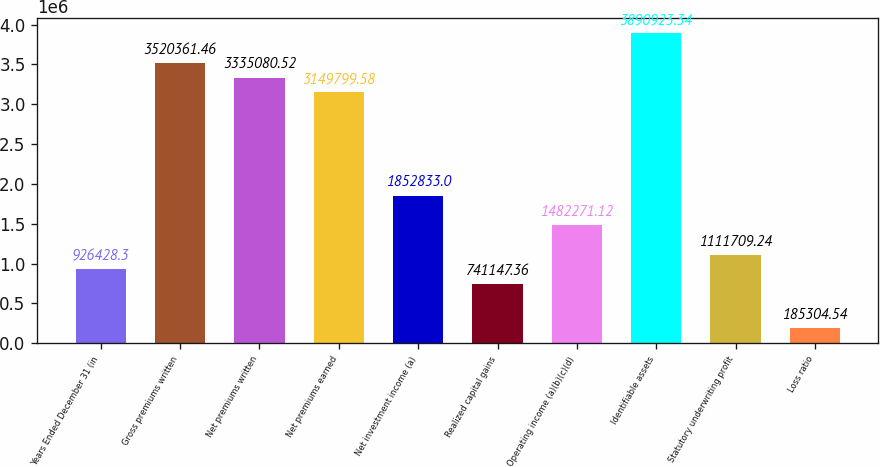Convert chart. <chart><loc_0><loc_0><loc_500><loc_500><bar_chart><fcel>Years Ended December 31 (in<fcel>Gross premiums written<fcel>Net premiums written<fcel>Net premiums earned<fcel>Net investment income (a)<fcel>Realized capital gains<fcel>Operating income (a)(b)(c)(d)<fcel>Identifiable assets<fcel>Statutory underwriting profit<fcel>Loss ratio<nl><fcel>926428<fcel>3.52036e+06<fcel>3.33508e+06<fcel>3.1498e+06<fcel>1.85283e+06<fcel>741147<fcel>1.48227e+06<fcel>3.89092e+06<fcel>1.11171e+06<fcel>185305<nl></chart> 